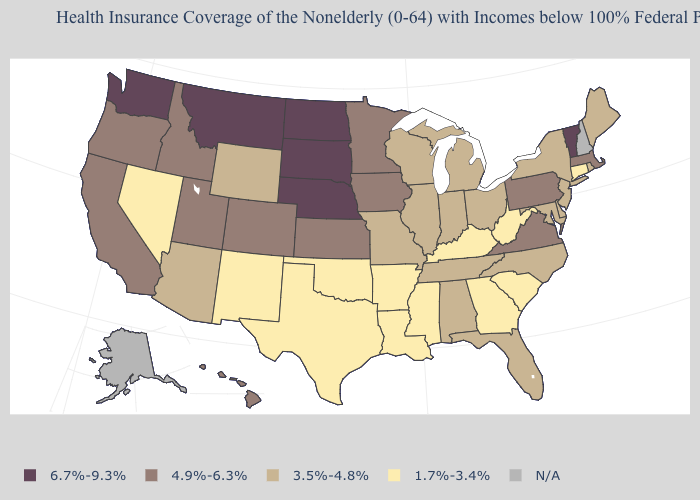What is the lowest value in the MidWest?
Keep it brief. 3.5%-4.8%. Does Washington have the highest value in the USA?
Be succinct. Yes. What is the value of Hawaii?
Quick response, please. 4.9%-6.3%. How many symbols are there in the legend?
Quick response, please. 5. Name the states that have a value in the range 1.7%-3.4%?
Be succinct. Arkansas, Connecticut, Georgia, Kentucky, Louisiana, Mississippi, Nevada, New Mexico, Oklahoma, South Carolina, Texas, West Virginia. What is the highest value in states that border Connecticut?
Concise answer only. 4.9%-6.3%. What is the highest value in states that border Utah?
Give a very brief answer. 4.9%-6.3%. What is the value of New Mexico?
Concise answer only. 1.7%-3.4%. Name the states that have a value in the range 6.7%-9.3%?
Concise answer only. Montana, Nebraska, North Dakota, South Dakota, Vermont, Washington. Does Ohio have the highest value in the MidWest?
Concise answer only. No. Does Washington have the lowest value in the West?
Write a very short answer. No. What is the lowest value in the Northeast?
Concise answer only. 1.7%-3.4%. Does Ohio have the highest value in the USA?
Keep it brief. No. What is the lowest value in the West?
Quick response, please. 1.7%-3.4%. Does Virginia have the highest value in the South?
Give a very brief answer. Yes. 